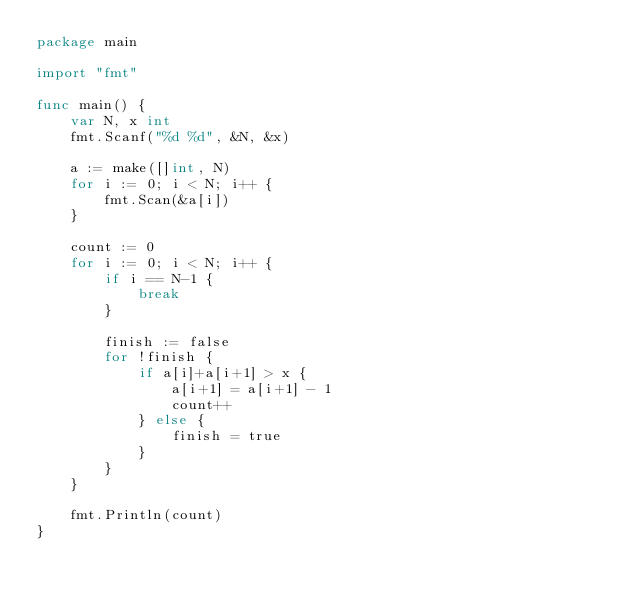<code> <loc_0><loc_0><loc_500><loc_500><_Go_>package main

import "fmt"

func main() {
	var N, x int
	fmt.Scanf("%d %d", &N, &x)

	a := make([]int, N)
	for i := 0; i < N; i++ {
		fmt.Scan(&a[i])
	}

	count := 0
	for i := 0; i < N; i++ {
		if i == N-1 {
			break
		}

		finish := false
		for !finish {
			if a[i]+a[i+1] > x {
				a[i+1] = a[i+1] - 1
				count++
			} else {
				finish = true
			}
		}
	}

	fmt.Println(count)
}</code> 